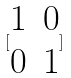<formula> <loc_0><loc_0><loc_500><loc_500>[ \begin{matrix} 1 & 0 \\ 0 & 1 \end{matrix} ]</formula> 